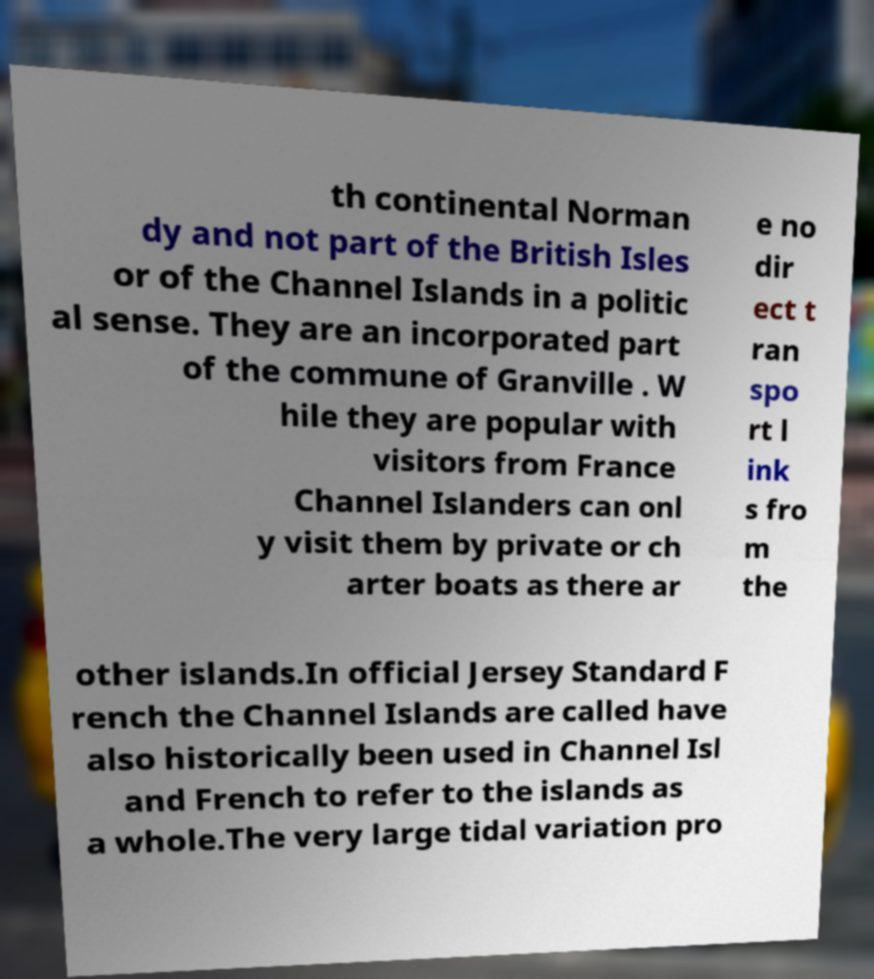For documentation purposes, I need the text within this image transcribed. Could you provide that? th continental Norman dy and not part of the British Isles or of the Channel Islands in a politic al sense. They are an incorporated part of the commune of Granville . W hile they are popular with visitors from France Channel Islanders can onl y visit them by private or ch arter boats as there ar e no dir ect t ran spo rt l ink s fro m the other islands.In official Jersey Standard F rench the Channel Islands are called have also historically been used in Channel Isl and French to refer to the islands as a whole.The very large tidal variation pro 